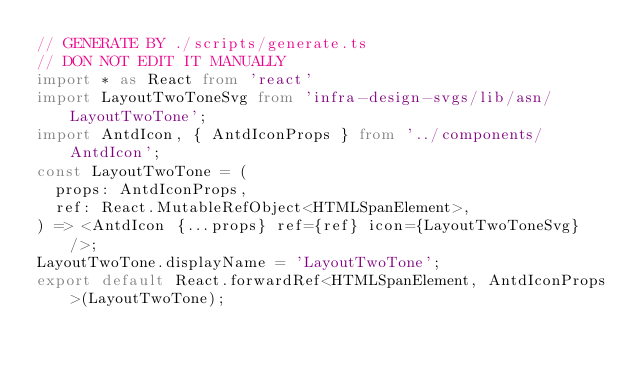<code> <loc_0><loc_0><loc_500><loc_500><_TypeScript_>// GENERATE BY ./scripts/generate.ts
// DON NOT EDIT IT MANUALLY
import * as React from 'react'
import LayoutTwoToneSvg from 'infra-design-svgs/lib/asn/LayoutTwoTone';
import AntdIcon, { AntdIconProps } from '../components/AntdIcon';
const LayoutTwoTone = (
  props: AntdIconProps,
  ref: React.MutableRefObject<HTMLSpanElement>,
) => <AntdIcon {...props} ref={ref} icon={LayoutTwoToneSvg} />;
LayoutTwoTone.displayName = 'LayoutTwoTone';
export default React.forwardRef<HTMLSpanElement, AntdIconProps>(LayoutTwoTone);</code> 